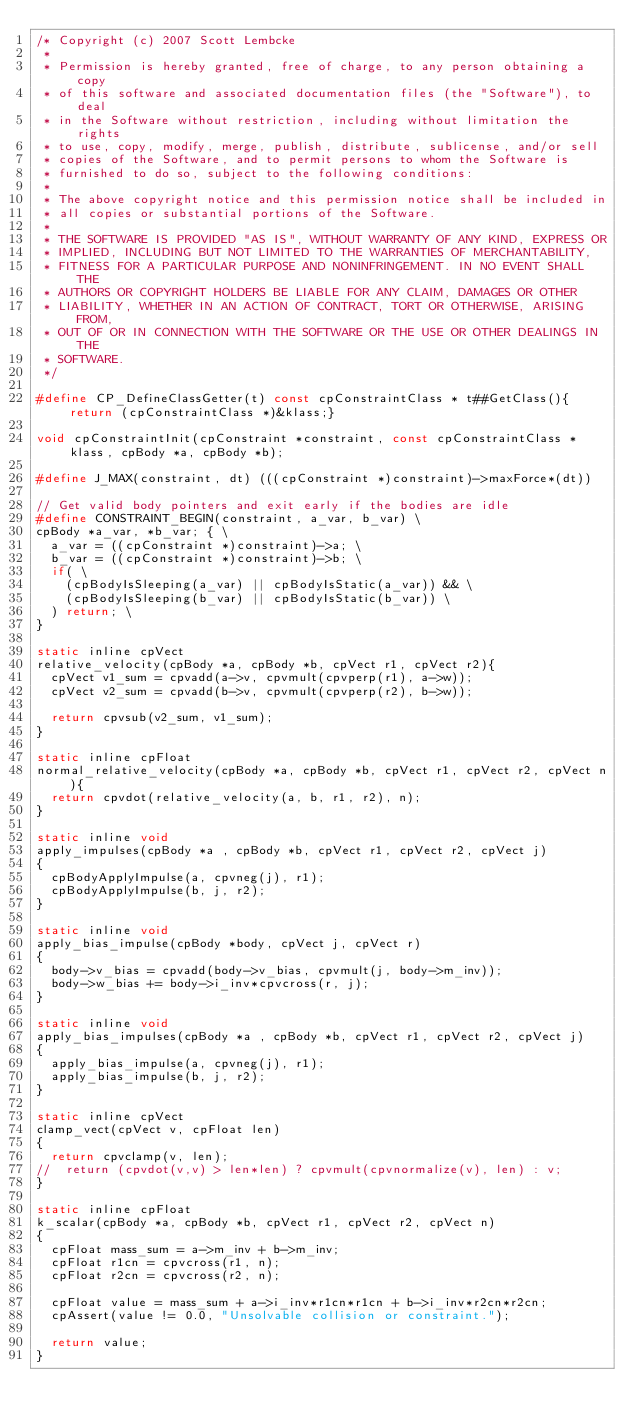<code> <loc_0><loc_0><loc_500><loc_500><_C_>/* Copyright (c) 2007 Scott Lembcke
 * 
 * Permission is hereby granted, free of charge, to any person obtaining a copy
 * of this software and associated documentation files (the "Software"), to deal
 * in the Software without restriction, including without limitation the rights
 * to use, copy, modify, merge, publish, distribute, sublicense, and/or sell
 * copies of the Software, and to permit persons to whom the Software is
 * furnished to do so, subject to the following conditions:
 * 
 * The above copyright notice and this permission notice shall be included in
 * all copies or substantial portions of the Software.
 * 
 * THE SOFTWARE IS PROVIDED "AS IS", WITHOUT WARRANTY OF ANY KIND, EXPRESS OR
 * IMPLIED, INCLUDING BUT NOT LIMITED TO THE WARRANTIES OF MERCHANTABILITY,
 * FITNESS FOR A PARTICULAR PURPOSE AND NONINFRINGEMENT. IN NO EVENT SHALL THE
 * AUTHORS OR COPYRIGHT HOLDERS BE LIABLE FOR ANY CLAIM, DAMAGES OR OTHER
 * LIABILITY, WHETHER IN AN ACTION OF CONTRACT, TORT OR OTHERWISE, ARISING FROM,
 * OUT OF OR IN CONNECTION WITH THE SOFTWARE OR THE USE OR OTHER DEALINGS IN THE
 * SOFTWARE.
 */

#define CP_DefineClassGetter(t) const cpConstraintClass * t##GetClass(){return (cpConstraintClass *)&klass;}

void cpConstraintInit(cpConstraint *constraint, const cpConstraintClass *klass, cpBody *a, cpBody *b);

#define J_MAX(constraint, dt) (((cpConstraint *)constraint)->maxForce*(dt))

// Get valid body pointers and exit early if the bodies are idle
#define CONSTRAINT_BEGIN(constraint, a_var, b_var) \
cpBody *a_var, *b_var; { \
	a_var = ((cpConstraint *)constraint)->a; \
	b_var = ((cpConstraint *)constraint)->b; \
	if( \
		(cpBodyIsSleeping(a_var) || cpBodyIsStatic(a_var)) && \
		(cpBodyIsSleeping(b_var) || cpBodyIsStatic(b_var)) \
	) return; \
}

static inline cpVect
relative_velocity(cpBody *a, cpBody *b, cpVect r1, cpVect r2){
	cpVect v1_sum = cpvadd(a->v, cpvmult(cpvperp(r1), a->w));
	cpVect v2_sum = cpvadd(b->v, cpvmult(cpvperp(r2), b->w));
	
	return cpvsub(v2_sum, v1_sum);
}

static inline cpFloat
normal_relative_velocity(cpBody *a, cpBody *b, cpVect r1, cpVect r2, cpVect n){
	return cpvdot(relative_velocity(a, b, r1, r2), n);
}

static inline void
apply_impulses(cpBody *a , cpBody *b, cpVect r1, cpVect r2, cpVect j)
{
	cpBodyApplyImpulse(a, cpvneg(j), r1);
	cpBodyApplyImpulse(b, j, r2);
}

static inline void
apply_bias_impulse(cpBody *body, cpVect j, cpVect r)
{
	body->v_bias = cpvadd(body->v_bias, cpvmult(j, body->m_inv));
	body->w_bias += body->i_inv*cpvcross(r, j);
}

static inline void
apply_bias_impulses(cpBody *a , cpBody *b, cpVect r1, cpVect r2, cpVect j)
{
	apply_bias_impulse(a, cpvneg(j), r1);
	apply_bias_impulse(b, j, r2);
}

static inline cpVect
clamp_vect(cpVect v, cpFloat len)
{
	return cpvclamp(v, len);
//	return (cpvdot(v,v) > len*len) ? cpvmult(cpvnormalize(v), len) : v;
}

static inline cpFloat
k_scalar(cpBody *a, cpBody *b, cpVect r1, cpVect r2, cpVect n)
{
	cpFloat mass_sum = a->m_inv + b->m_inv;
	cpFloat r1cn = cpvcross(r1, n);
	cpFloat r2cn = cpvcross(r2, n);
	
	cpFloat value = mass_sum + a->i_inv*r1cn*r1cn + b->i_inv*r2cn*r2cn;
	cpAssert(value != 0.0, "Unsolvable collision or constraint.");
	
	return value;
}
</code> 